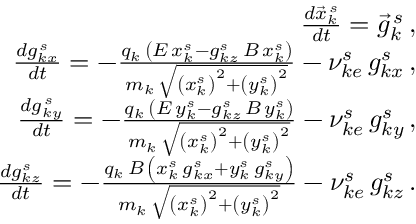<formula> <loc_0><loc_0><loc_500><loc_500>\begin{array} { r l r } & { \frac { d \vec { x } _ { k } ^ { \, s } } { d t } = \vec { g } _ { k } ^ { \, s } \, , } \\ & { \frac { d g _ { k x } ^ { \, s } } { d t } = - \frac { q _ { k } \, \left ( E \, x _ { k } ^ { s } - g _ { k z } ^ { s } \, B \, x _ { k } ^ { s } \right ) } { m _ { k } \, \sqrt { \left ( x _ { k } ^ { s } \right ) ^ { 2 } + \left ( y _ { k } ^ { s } \right ) ^ { 2 } } } - \nu _ { k e } ^ { s } \, g _ { k x } ^ { s } \, , } \\ & { \frac { d g _ { k y } ^ { \, s } } { d t } = - \frac { q _ { k } \, \left ( E \, y _ { k } ^ { s } - g _ { k z } ^ { s } \, B \, y _ { k } ^ { s } \right ) } { m _ { k } \, \sqrt { \left ( x _ { k } ^ { s } \right ) ^ { 2 } + \left ( y _ { k } ^ { s } \right ) ^ { 2 } } } - \nu _ { k e } ^ { s } \, g _ { k y } ^ { s } \, , } \\ & { \frac { d g _ { k z } ^ { s } } { d t } = - \frac { q _ { k } \, B \, \left ( x _ { k } ^ { s } \, g _ { k x } ^ { s } + y _ { k } ^ { s } \, g _ { k y } ^ { s } \right ) } { m _ { k } \, \sqrt { \left ( x _ { k } ^ { s } \right ) ^ { 2 } + \left ( y _ { k } ^ { s } \right ) ^ { 2 } } } - \nu _ { k e } ^ { s } \, g _ { k z } ^ { s } \, . } \end{array}</formula> 